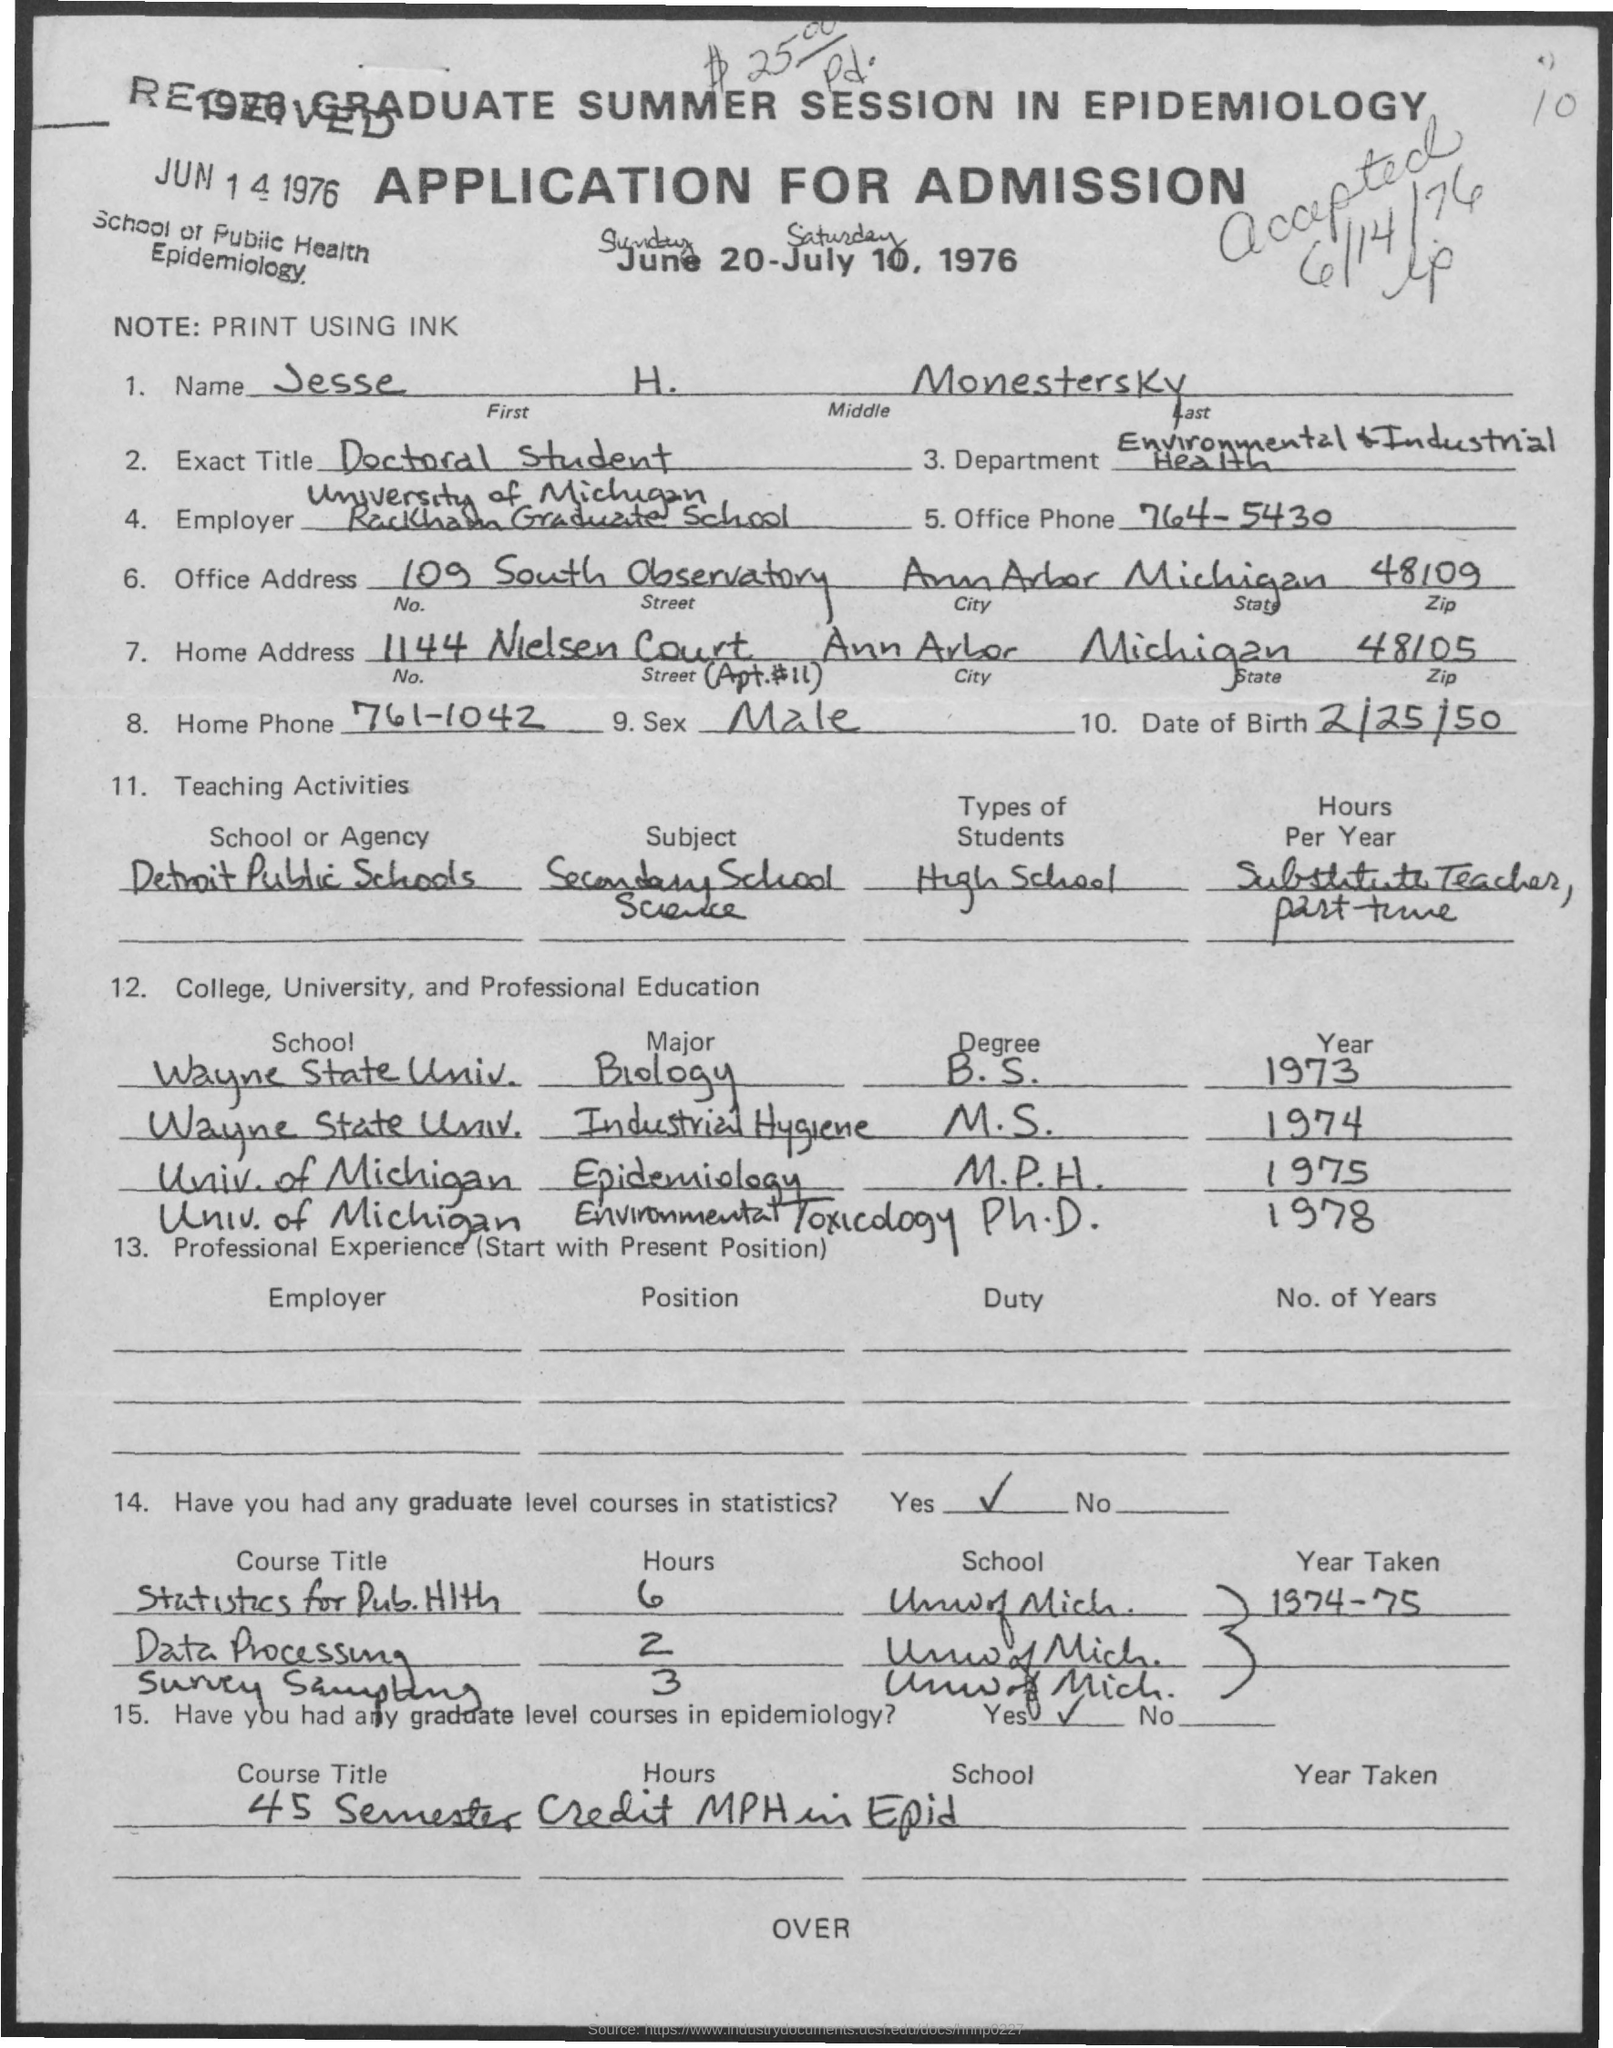What is the office phone number
Ensure brevity in your answer.  764-5430. What is the zipcode of office address
Make the answer very short. 48109. What is the zip code of home address
Offer a terse response. 48105. What is the name mentioned ?
Provide a succinct answer. Jesse H. Monestersky. What is the exact title ?
Provide a short and direct response. Doctoral Student. What is the home phone number
Your answer should be compact. 761-1042. What  is the date of birth ?
Provide a short and direct response. 2/25/50. 